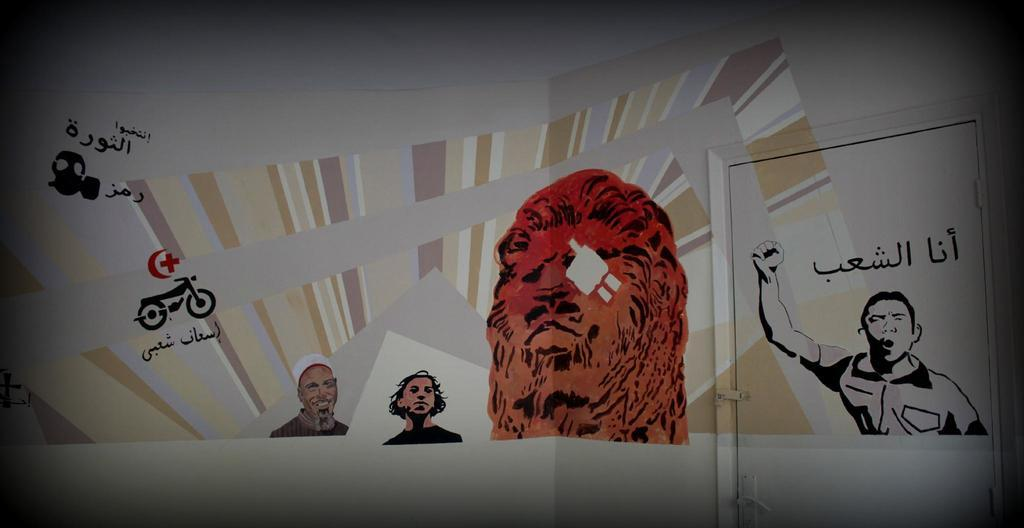What type of images can be seen in the picture? There are cartoon images in the image. Is there any text present in the image? Yes, text is visible in the image. Can you see a trail leading into a cave in the image? There is no trail or cave present in the image; it features cartoon images and text. 